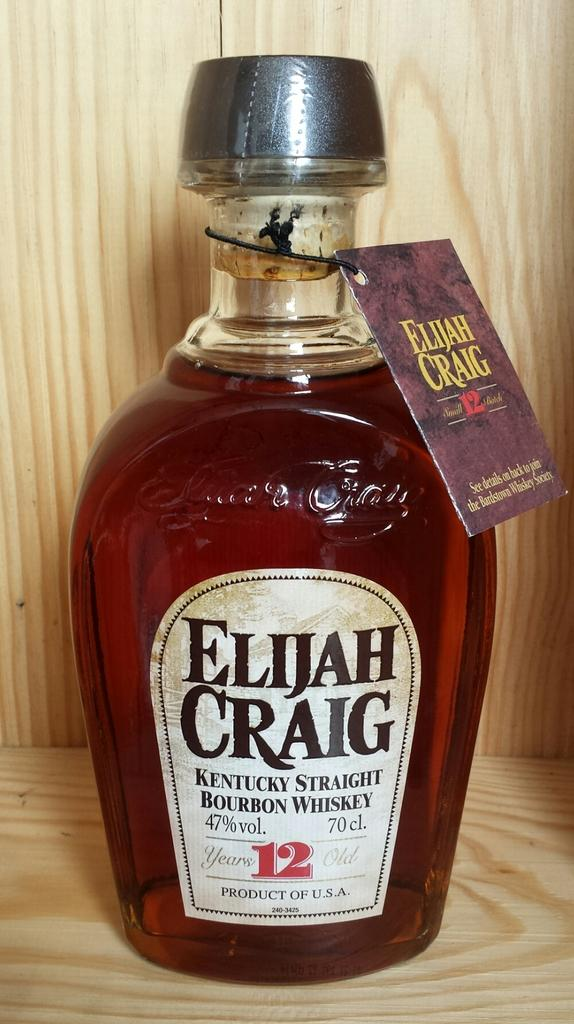What type of container is visible in the image? There is a glass bottle in the image. What is written on the bottle? The name "Elijah Craig" is on the bottle. Can you see any twigs growing out of the bottle in the image? No, there are no twigs present in the image. 